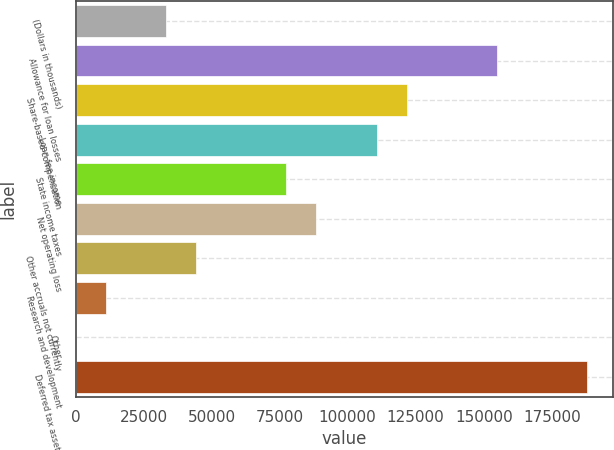<chart> <loc_0><loc_0><loc_500><loc_500><bar_chart><fcel>(Dollars in thousands)<fcel>Allowance for loan losses<fcel>Share-based compensation<fcel>Loan fee income<fcel>State income taxes<fcel>Net operating loss<fcel>Other accruals not currently<fcel>Research and development<fcel>Other<fcel>Deferred tax assets<nl><fcel>33200.2<fcel>154876<fcel>121691<fcel>110630<fcel>77445.8<fcel>88507.2<fcel>44261.6<fcel>11077.4<fcel>16<fcel>188060<nl></chart> 